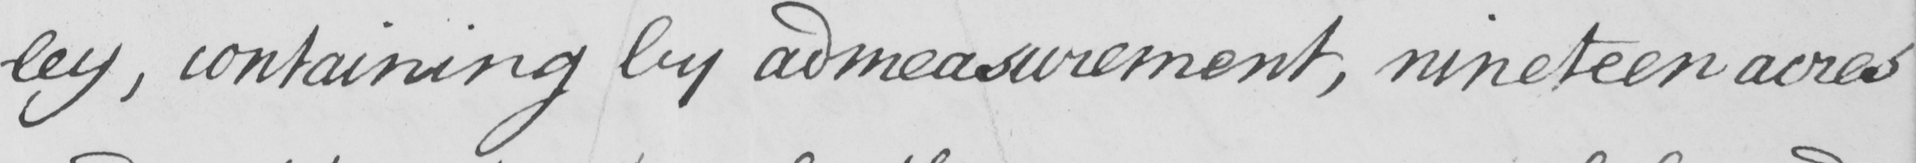What does this handwritten line say? -ley , containing by admeasurement , nineteen acres 